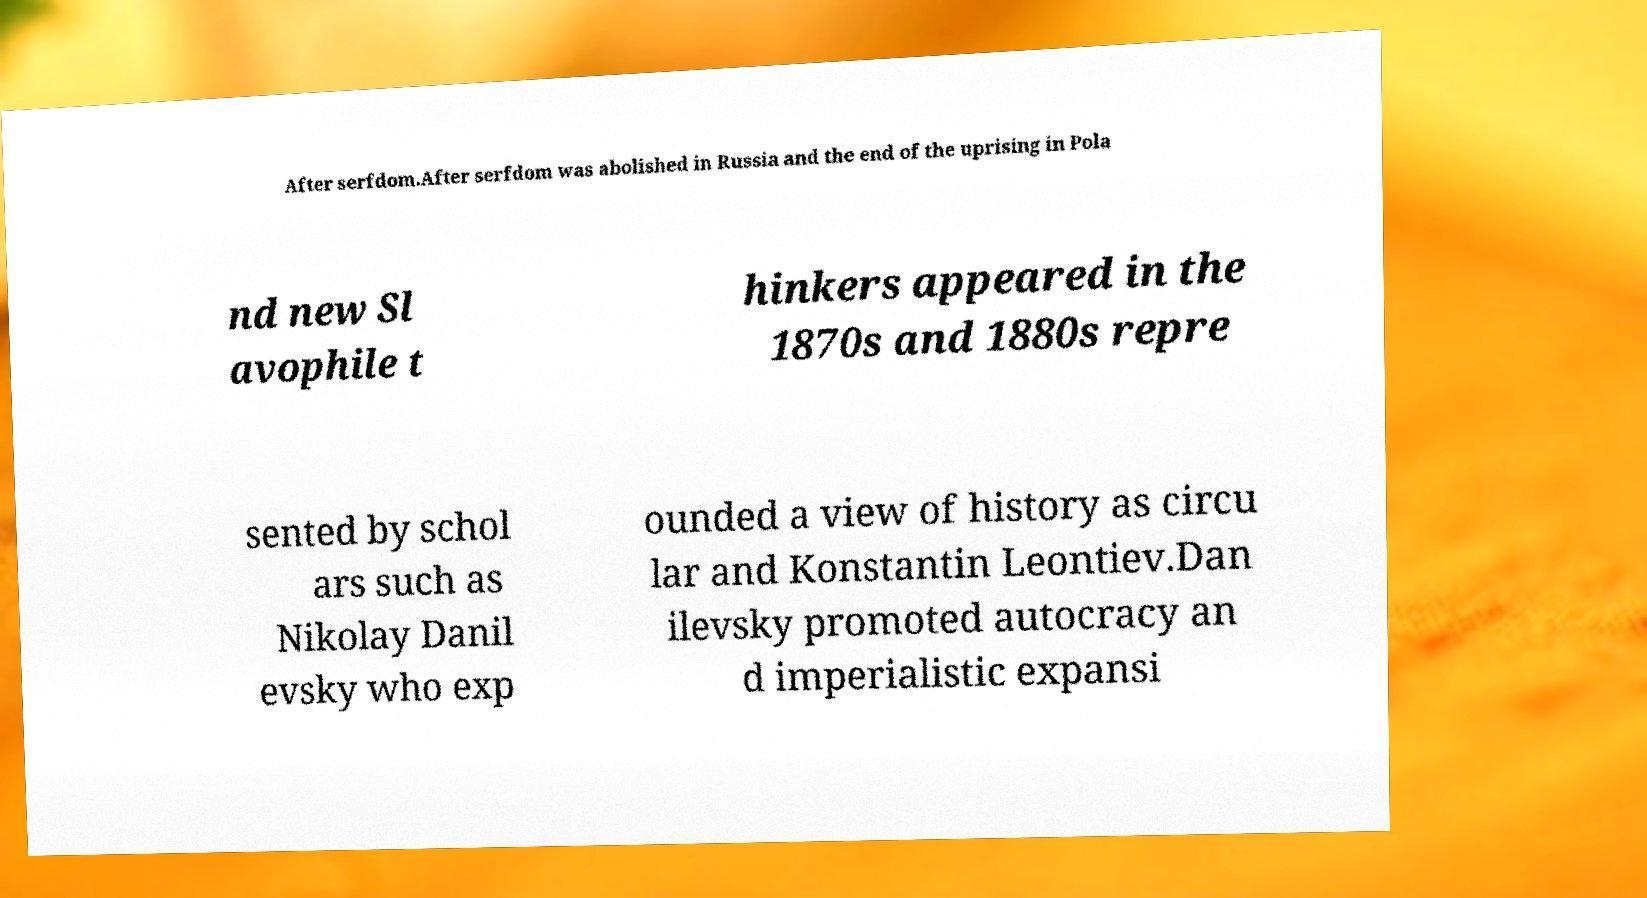Could you extract and type out the text from this image? After serfdom.After serfdom was abolished in Russia and the end of the uprising in Pola nd new Sl avophile t hinkers appeared in the 1870s and 1880s repre sented by schol ars such as Nikolay Danil evsky who exp ounded a view of history as circu lar and Konstantin Leontiev.Dan ilevsky promoted autocracy an d imperialistic expansi 